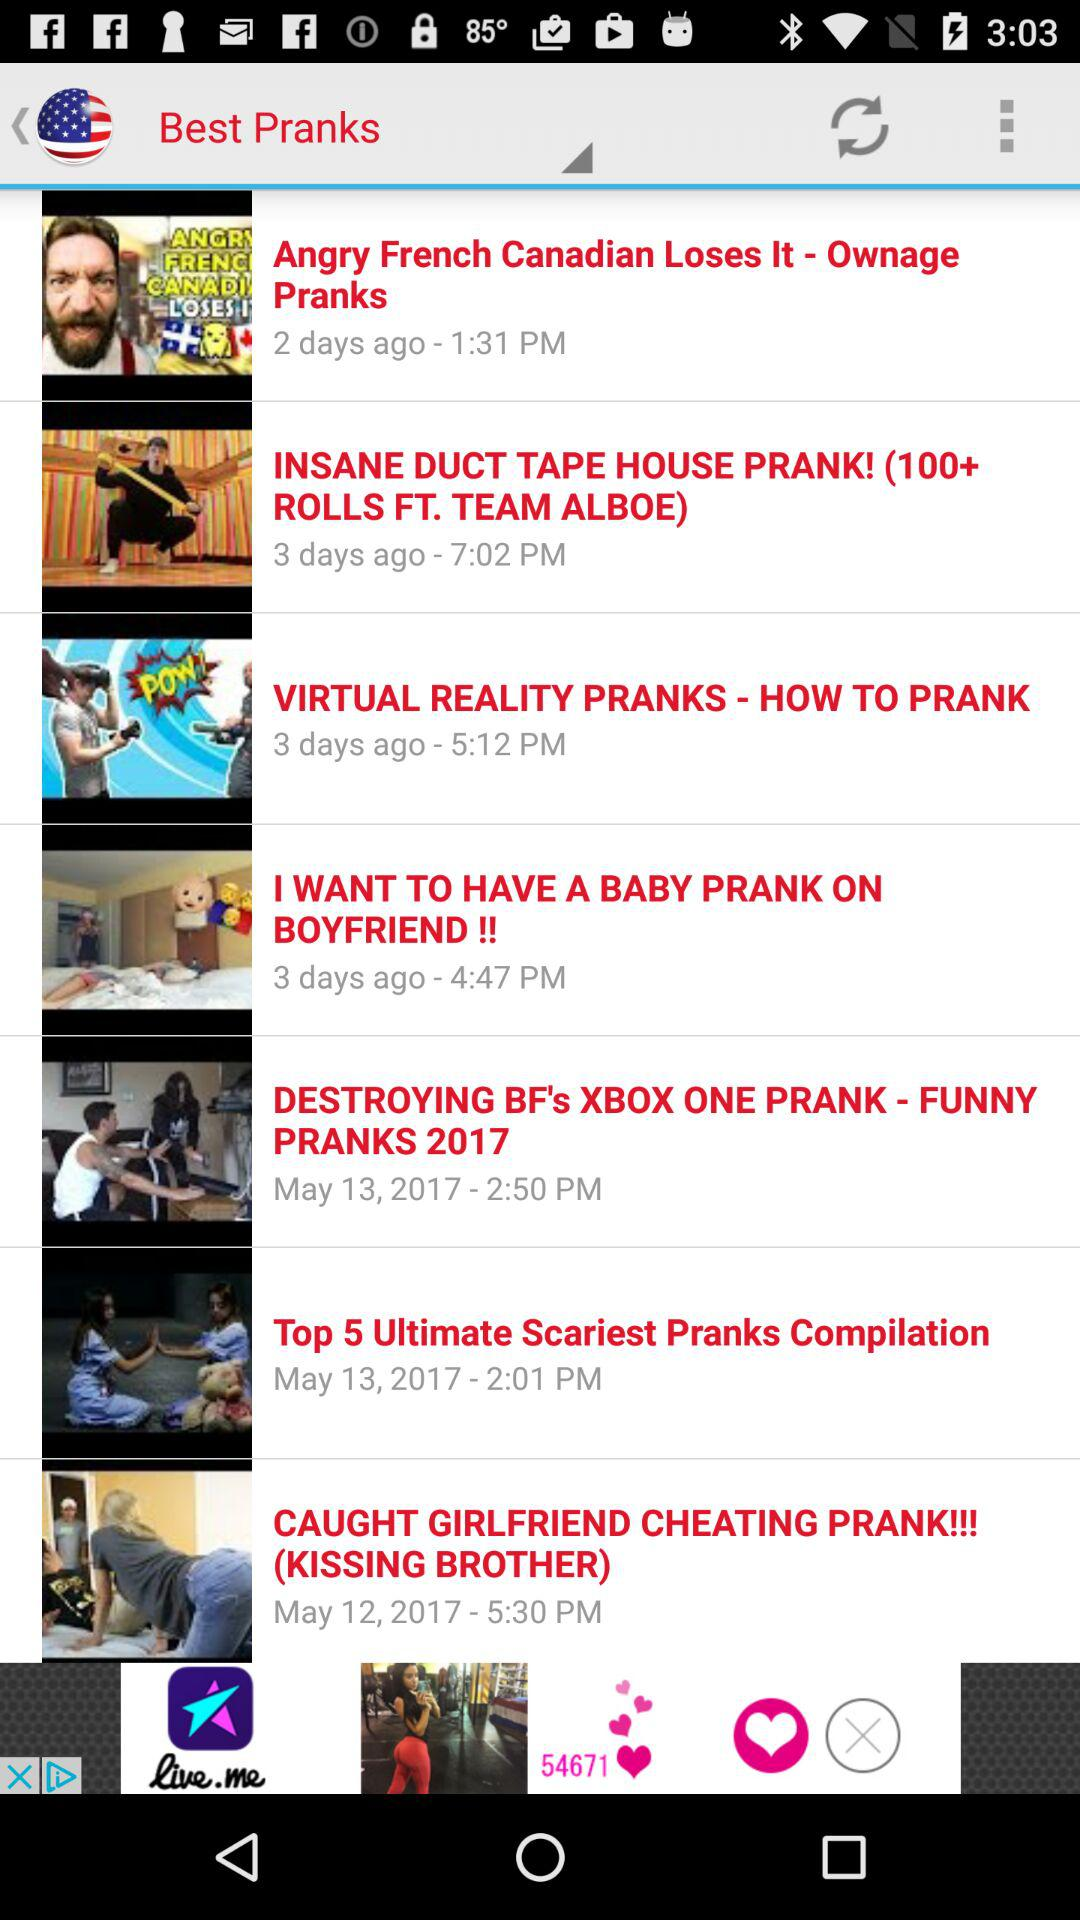What is the posted time of the video "CAUGHT GIRLFRIEND CHEATING PRANK"? The posted time is 5:30 p.m. 